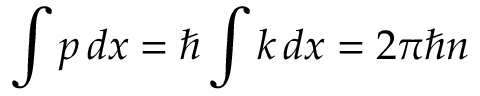<formula> <loc_0><loc_0><loc_500><loc_500>\int p \, d x = \hbar { \int } k \, d x = 2 \pi \hbar { n }</formula> 